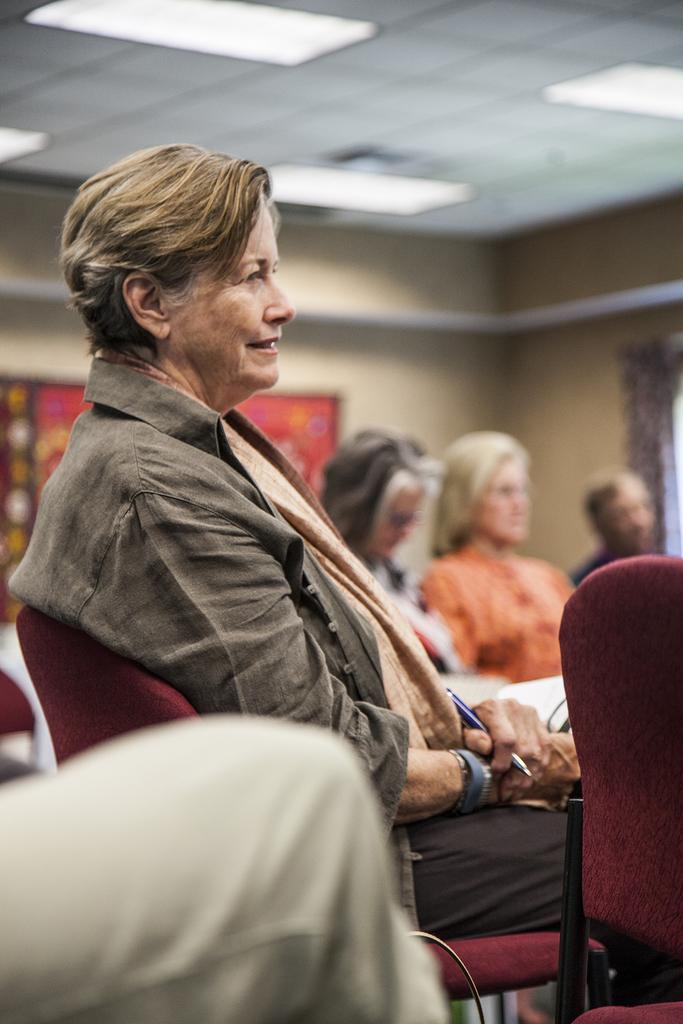How many people are in the image? There are people in the image. What is the position of one of the people in the image? One person is sitting. What is the sitting person holding? The sitting person is holding a pen. What type of bread is the visitor holding in the image? There is no visitor or bread present in the image. 